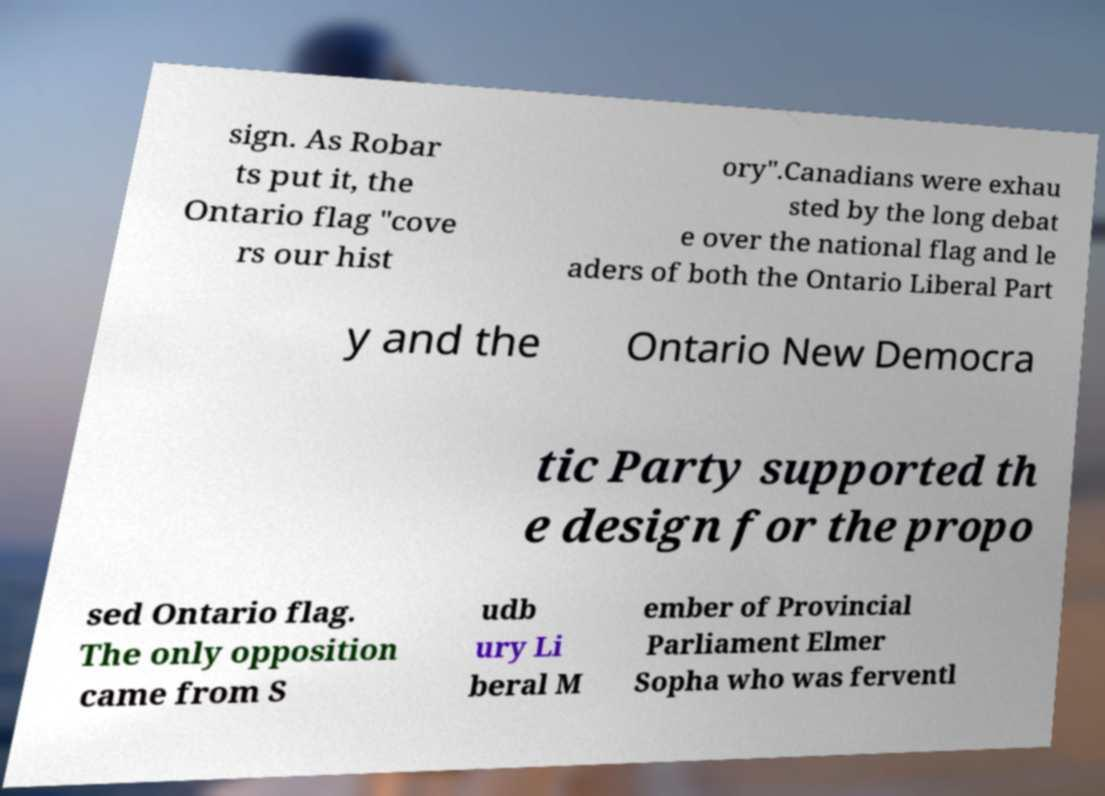For documentation purposes, I need the text within this image transcribed. Could you provide that? sign. As Robar ts put it, the Ontario flag "cove rs our hist ory".Canadians were exhau sted by the long debat e over the national flag and le aders of both the Ontario Liberal Part y and the Ontario New Democra tic Party supported th e design for the propo sed Ontario flag. The only opposition came from S udb ury Li beral M ember of Provincial Parliament Elmer Sopha who was ferventl 